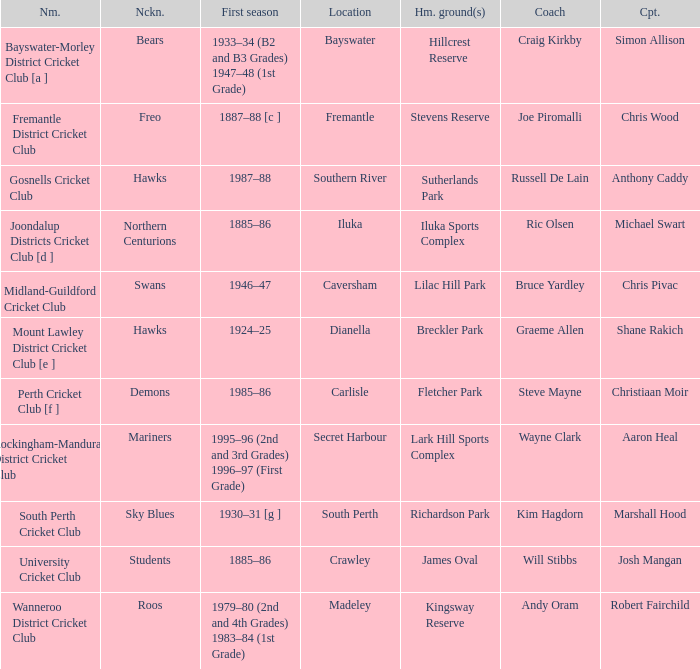With the nickname the swans, what is the home ground? Lilac Hill Park. Give me the full table as a dictionary. {'header': ['Nm.', 'Nckn.', 'First season', 'Location', 'Hm. ground(s)', 'Coach', 'Cpt.'], 'rows': [['Bayswater-Morley District Cricket Club [a ]', 'Bears', '1933–34 (B2 and B3 Grades) 1947–48 (1st Grade)', 'Bayswater', 'Hillcrest Reserve', 'Craig Kirkby', 'Simon Allison'], ['Fremantle District Cricket Club', 'Freo', '1887–88 [c ]', 'Fremantle', 'Stevens Reserve', 'Joe Piromalli', 'Chris Wood'], ['Gosnells Cricket Club', 'Hawks', '1987–88', 'Southern River', 'Sutherlands Park', 'Russell De Lain', 'Anthony Caddy'], ['Joondalup Districts Cricket Club [d ]', 'Northern Centurions', '1885–86', 'Iluka', 'Iluka Sports Complex', 'Ric Olsen', 'Michael Swart'], ['Midland-Guildford Cricket Club', 'Swans', '1946–47', 'Caversham', 'Lilac Hill Park', 'Bruce Yardley', 'Chris Pivac'], ['Mount Lawley District Cricket Club [e ]', 'Hawks', '1924–25', 'Dianella', 'Breckler Park', 'Graeme Allen', 'Shane Rakich'], ['Perth Cricket Club [f ]', 'Demons', '1985–86', 'Carlisle', 'Fletcher Park', 'Steve Mayne', 'Christiaan Moir'], ['Rockingham-Mandurah District Cricket Club', 'Mariners', '1995–96 (2nd and 3rd Grades) 1996–97 (First Grade)', 'Secret Harbour', 'Lark Hill Sports Complex', 'Wayne Clark', 'Aaron Heal'], ['South Perth Cricket Club', 'Sky Blues', '1930–31 [g ]', 'South Perth', 'Richardson Park', 'Kim Hagdorn', 'Marshall Hood'], ['University Cricket Club', 'Students', '1885–86', 'Crawley', 'James Oval', 'Will Stibbs', 'Josh Mangan'], ['Wanneroo District Cricket Club', 'Roos', '1979–80 (2nd and 4th Grades) 1983–84 (1st Grade)', 'Madeley', 'Kingsway Reserve', 'Andy Oram', 'Robert Fairchild']]} 